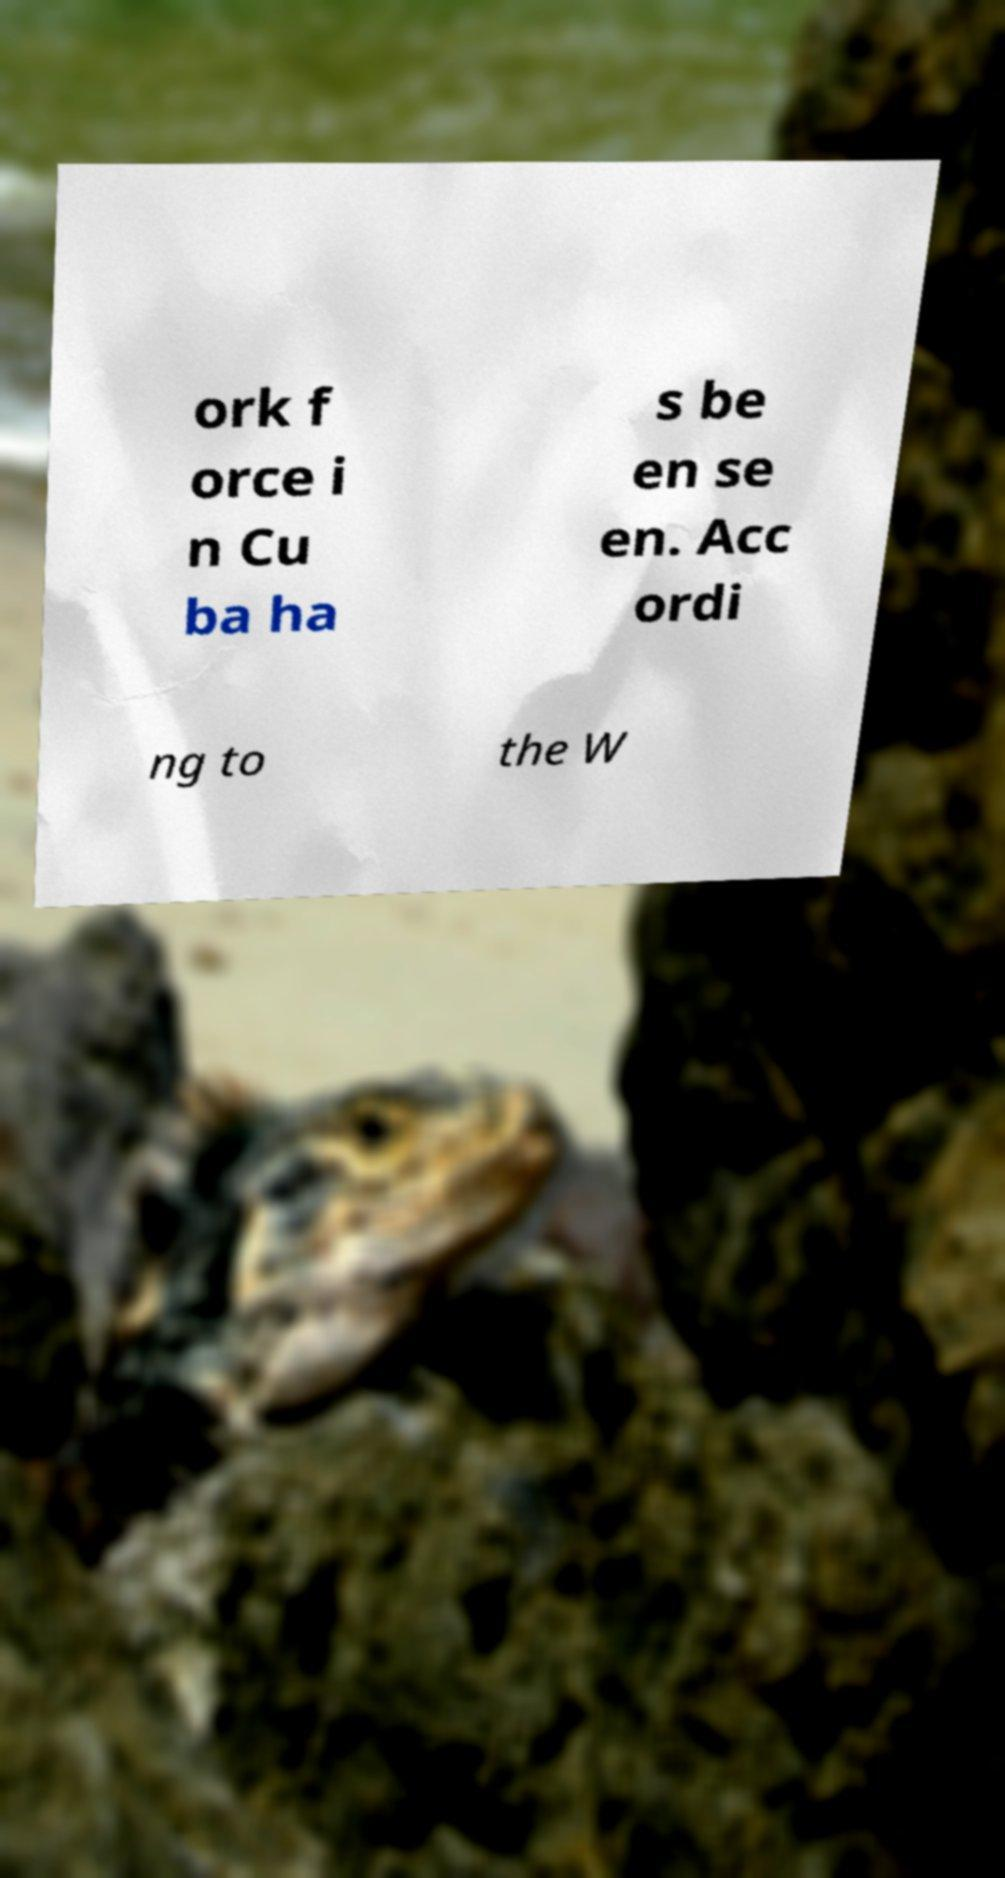What messages or text are displayed in this image? I need them in a readable, typed format. ork f orce i n Cu ba ha s be en se en. Acc ordi ng to the W 